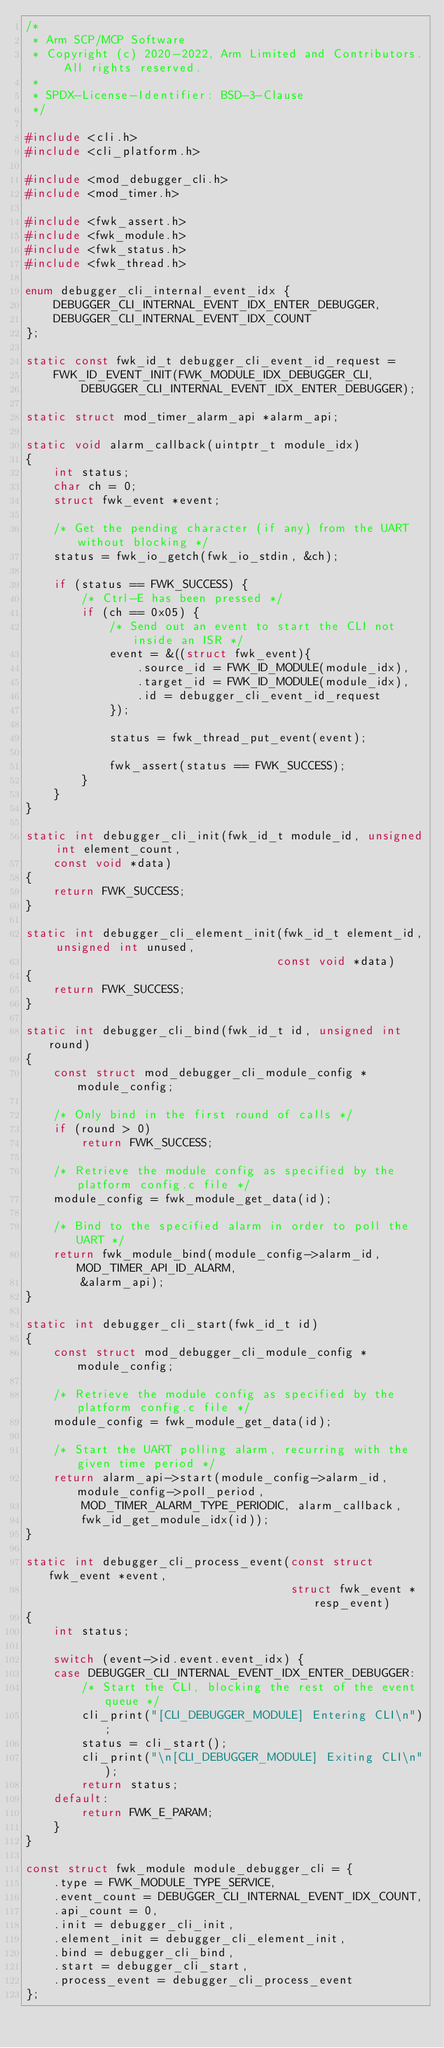<code> <loc_0><loc_0><loc_500><loc_500><_C_>/*
 * Arm SCP/MCP Software
 * Copyright (c) 2020-2022, Arm Limited and Contributors. All rights reserved.
 *
 * SPDX-License-Identifier: BSD-3-Clause
 */

#include <cli.h>
#include <cli_platform.h>

#include <mod_debugger_cli.h>
#include <mod_timer.h>

#include <fwk_assert.h>
#include <fwk_module.h>
#include <fwk_status.h>
#include <fwk_thread.h>

enum debugger_cli_internal_event_idx {
    DEBUGGER_CLI_INTERNAL_EVENT_IDX_ENTER_DEBUGGER,
    DEBUGGER_CLI_INTERNAL_EVENT_IDX_COUNT
};

static const fwk_id_t debugger_cli_event_id_request =
    FWK_ID_EVENT_INIT(FWK_MODULE_IDX_DEBUGGER_CLI,
        DEBUGGER_CLI_INTERNAL_EVENT_IDX_ENTER_DEBUGGER);

static struct mod_timer_alarm_api *alarm_api;

static void alarm_callback(uintptr_t module_idx)
{
    int status;
    char ch = 0;
    struct fwk_event *event;

    /* Get the pending character (if any) from the UART without blocking */
    status = fwk_io_getch(fwk_io_stdin, &ch);

    if (status == FWK_SUCCESS) {
        /* Ctrl-E has been pressed */
        if (ch == 0x05) {
            /* Send out an event to start the CLI not inside an ISR */
            event = &((struct fwk_event){
                .source_id = FWK_ID_MODULE(module_idx),
                .target_id = FWK_ID_MODULE(module_idx),
                .id = debugger_cli_event_id_request
            });

            status = fwk_thread_put_event(event);

            fwk_assert(status == FWK_SUCCESS);
        }
    }
}

static int debugger_cli_init(fwk_id_t module_id, unsigned int element_count,
    const void *data)
{
    return FWK_SUCCESS;
}

static int debugger_cli_element_init(fwk_id_t element_id, unsigned int unused,
                                    const void *data)
{
    return FWK_SUCCESS;
}

static int debugger_cli_bind(fwk_id_t id, unsigned int round)
{
    const struct mod_debugger_cli_module_config *module_config;

    /* Only bind in the first round of calls */
    if (round > 0)
        return FWK_SUCCESS;

    /* Retrieve the module config as specified by the platform config.c file */
    module_config = fwk_module_get_data(id);

    /* Bind to the specified alarm in order to poll the UART */
    return fwk_module_bind(module_config->alarm_id, MOD_TIMER_API_ID_ALARM,
        &alarm_api);
}

static int debugger_cli_start(fwk_id_t id)
{
    const struct mod_debugger_cli_module_config *module_config;

    /* Retrieve the module config as specified by the platform config.c file */
    module_config = fwk_module_get_data(id);

    /* Start the UART polling alarm, recurring with the given time period */
    return alarm_api->start(module_config->alarm_id, module_config->poll_period,
        MOD_TIMER_ALARM_TYPE_PERIODIC, alarm_callback,
        fwk_id_get_module_idx(id));
}

static int debugger_cli_process_event(const struct fwk_event *event,
                                      struct fwk_event *resp_event)
{
    int status;

    switch (event->id.event.event_idx) {
    case DEBUGGER_CLI_INTERNAL_EVENT_IDX_ENTER_DEBUGGER:
        /* Start the CLI, blocking the rest of the event queue */
        cli_print("[CLI_DEBUGGER_MODULE] Entering CLI\n");
        status = cli_start();
        cli_print("\n[CLI_DEBUGGER_MODULE] Exiting CLI\n");
        return status;
    default:
        return FWK_E_PARAM;
    }
}

const struct fwk_module module_debugger_cli = {
    .type = FWK_MODULE_TYPE_SERVICE,
    .event_count = DEBUGGER_CLI_INTERNAL_EVENT_IDX_COUNT,
    .api_count = 0,
    .init = debugger_cli_init,
    .element_init = debugger_cli_element_init,
    .bind = debugger_cli_bind,
    .start = debugger_cli_start,
    .process_event = debugger_cli_process_event
};
</code> 